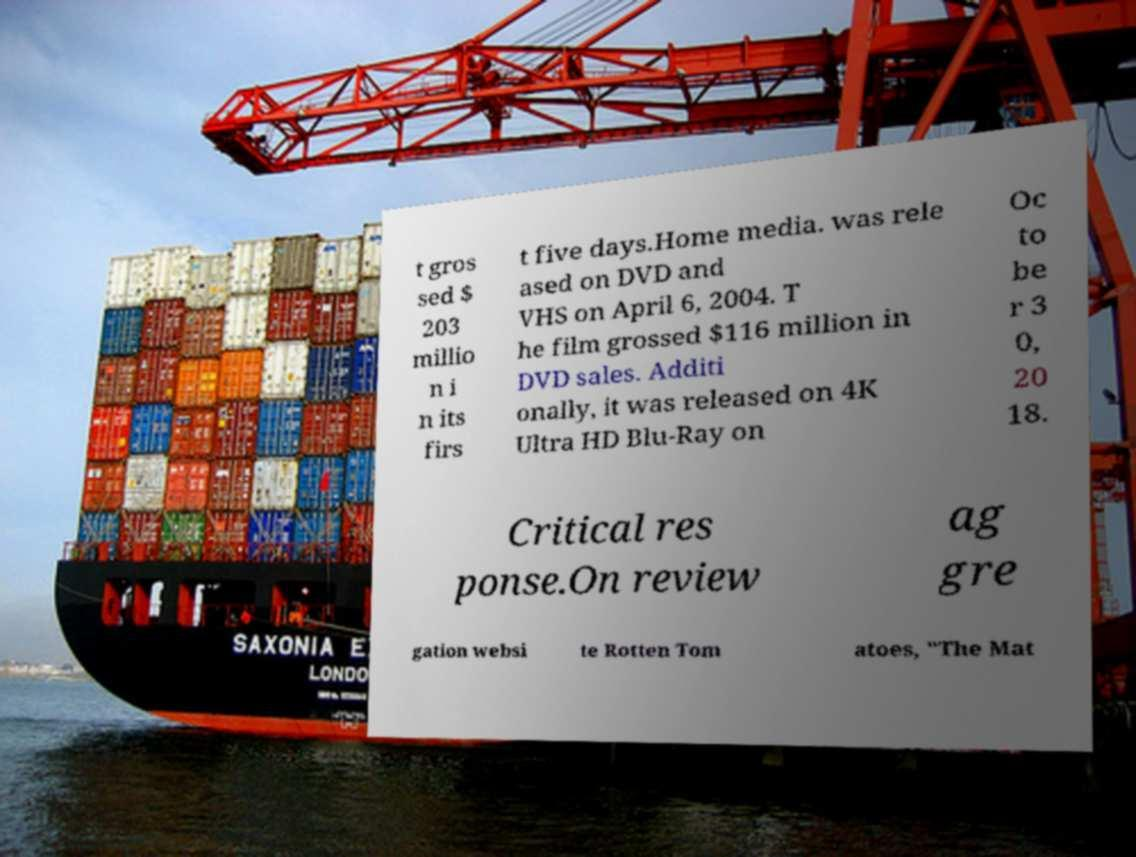I need the written content from this picture converted into text. Can you do that? t gros sed $ 203 millio n i n its firs t five days.Home media. was rele ased on DVD and VHS on April 6, 2004. T he film grossed $116 million in DVD sales. Additi onally, it was released on 4K Ultra HD Blu-Ray on Oc to be r 3 0, 20 18. Critical res ponse.On review ag gre gation websi te Rotten Tom atoes, "The Mat 